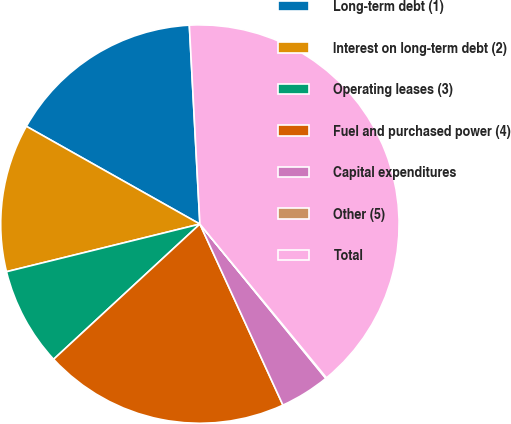Convert chart to OTSL. <chart><loc_0><loc_0><loc_500><loc_500><pie_chart><fcel>Long-term debt (1)<fcel>Interest on long-term debt (2)<fcel>Operating leases (3)<fcel>Fuel and purchased power (4)<fcel>Capital expenditures<fcel>Other (5)<fcel>Total<nl><fcel>15.99%<fcel>12.01%<fcel>8.03%<fcel>19.97%<fcel>4.05%<fcel>0.07%<fcel>39.88%<nl></chart> 